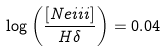Convert formula to latex. <formula><loc_0><loc_0><loc_500><loc_500>\log \left ( \frac { [ N e { i i i } ] } { H \delta } \right ) = 0 . 0 4</formula> 